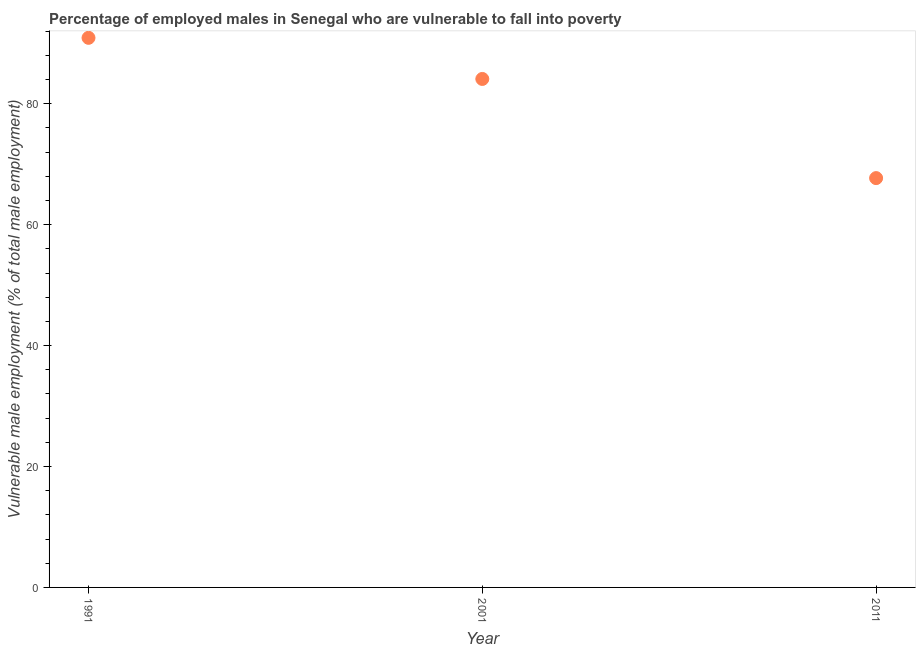What is the percentage of employed males who are vulnerable to fall into poverty in 2011?
Provide a short and direct response. 67.7. Across all years, what is the maximum percentage of employed males who are vulnerable to fall into poverty?
Your answer should be very brief. 90.9. Across all years, what is the minimum percentage of employed males who are vulnerable to fall into poverty?
Your answer should be very brief. 67.7. In which year was the percentage of employed males who are vulnerable to fall into poverty minimum?
Give a very brief answer. 2011. What is the sum of the percentage of employed males who are vulnerable to fall into poverty?
Your answer should be compact. 242.7. What is the difference between the percentage of employed males who are vulnerable to fall into poverty in 1991 and 2001?
Make the answer very short. 6.8. What is the average percentage of employed males who are vulnerable to fall into poverty per year?
Keep it short and to the point. 80.9. What is the median percentage of employed males who are vulnerable to fall into poverty?
Ensure brevity in your answer.  84.1. In how many years, is the percentage of employed males who are vulnerable to fall into poverty greater than 4 %?
Your answer should be very brief. 3. Do a majority of the years between 2001 and 1991 (inclusive) have percentage of employed males who are vulnerable to fall into poverty greater than 72 %?
Offer a terse response. No. What is the ratio of the percentage of employed males who are vulnerable to fall into poverty in 1991 to that in 2011?
Your answer should be compact. 1.34. Is the percentage of employed males who are vulnerable to fall into poverty in 2001 less than that in 2011?
Ensure brevity in your answer.  No. What is the difference between the highest and the second highest percentage of employed males who are vulnerable to fall into poverty?
Keep it short and to the point. 6.8. Is the sum of the percentage of employed males who are vulnerable to fall into poverty in 1991 and 2011 greater than the maximum percentage of employed males who are vulnerable to fall into poverty across all years?
Provide a short and direct response. Yes. What is the difference between the highest and the lowest percentage of employed males who are vulnerable to fall into poverty?
Offer a terse response. 23.2. Does the percentage of employed males who are vulnerable to fall into poverty monotonically increase over the years?
Provide a short and direct response. No. Does the graph contain any zero values?
Give a very brief answer. No. What is the title of the graph?
Your answer should be very brief. Percentage of employed males in Senegal who are vulnerable to fall into poverty. What is the label or title of the X-axis?
Your answer should be compact. Year. What is the label or title of the Y-axis?
Your answer should be very brief. Vulnerable male employment (% of total male employment). What is the Vulnerable male employment (% of total male employment) in 1991?
Offer a terse response. 90.9. What is the Vulnerable male employment (% of total male employment) in 2001?
Keep it short and to the point. 84.1. What is the Vulnerable male employment (% of total male employment) in 2011?
Ensure brevity in your answer.  67.7. What is the difference between the Vulnerable male employment (% of total male employment) in 1991 and 2001?
Ensure brevity in your answer.  6.8. What is the difference between the Vulnerable male employment (% of total male employment) in 1991 and 2011?
Offer a very short reply. 23.2. What is the ratio of the Vulnerable male employment (% of total male employment) in 1991 to that in 2001?
Your answer should be very brief. 1.08. What is the ratio of the Vulnerable male employment (% of total male employment) in 1991 to that in 2011?
Your response must be concise. 1.34. What is the ratio of the Vulnerable male employment (% of total male employment) in 2001 to that in 2011?
Keep it short and to the point. 1.24. 